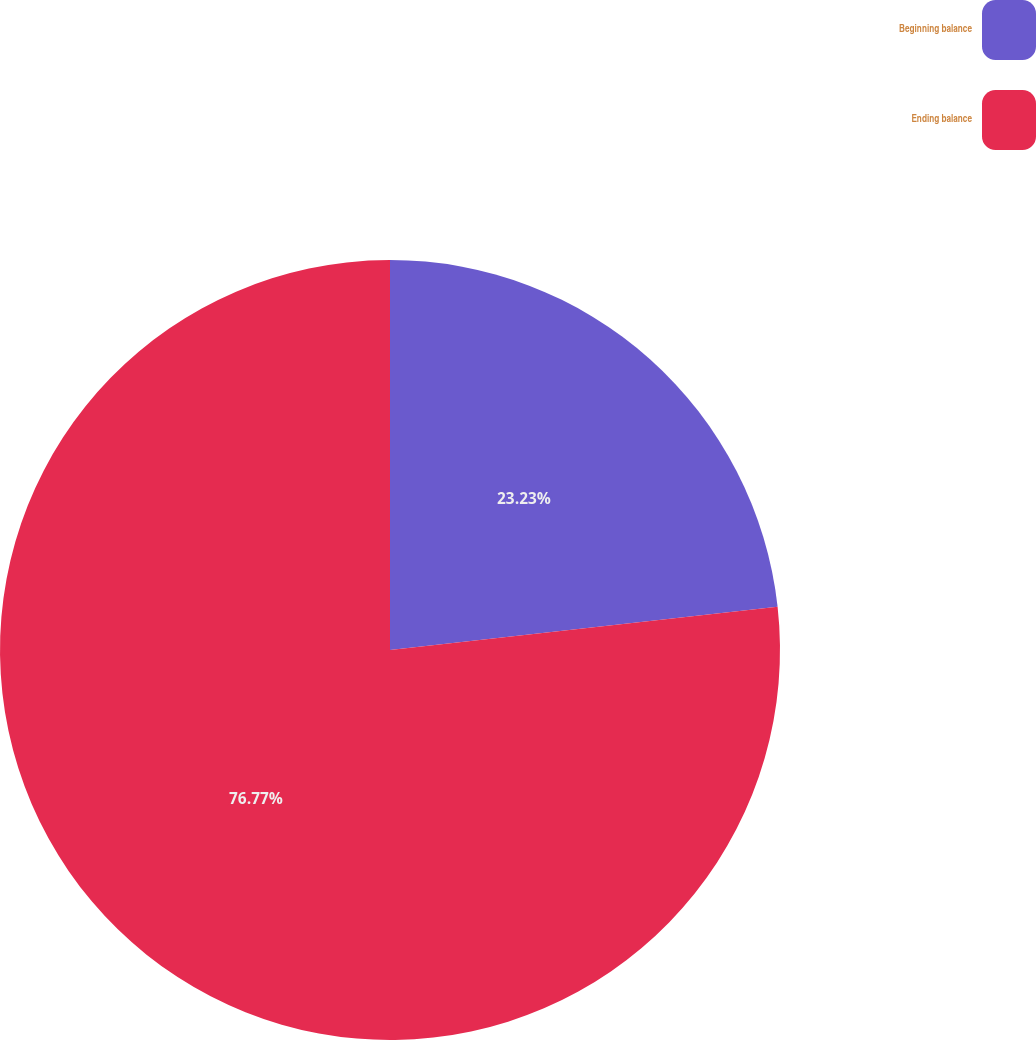Convert chart to OTSL. <chart><loc_0><loc_0><loc_500><loc_500><pie_chart><fcel>Beginning balance<fcel>Ending balance<nl><fcel>23.23%<fcel>76.77%<nl></chart> 